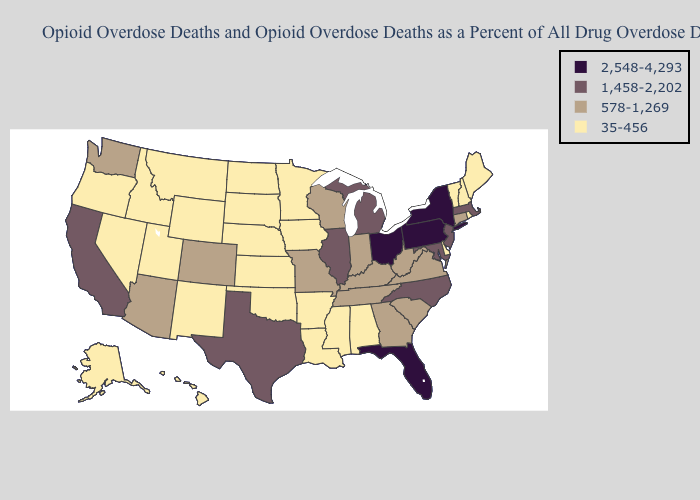Does Arkansas have a lower value than Wyoming?
Answer briefly. No. Does Missouri have the lowest value in the MidWest?
Give a very brief answer. No. What is the value of Texas?
Concise answer only. 1,458-2,202. What is the highest value in the USA?
Be succinct. 2,548-4,293. Does the first symbol in the legend represent the smallest category?
Answer briefly. No. Name the states that have a value in the range 578-1,269?
Write a very short answer. Arizona, Colorado, Connecticut, Georgia, Indiana, Kentucky, Missouri, South Carolina, Tennessee, Virginia, Washington, West Virginia, Wisconsin. What is the highest value in the MidWest ?
Answer briefly. 2,548-4,293. Name the states that have a value in the range 2,548-4,293?
Be succinct. Florida, New York, Ohio, Pennsylvania. Does Michigan have a higher value than Massachusetts?
Answer briefly. No. Does Alabama have the lowest value in the South?
Quick response, please. Yes. Which states have the lowest value in the USA?
Answer briefly. Alabama, Alaska, Arkansas, Delaware, Hawaii, Idaho, Iowa, Kansas, Louisiana, Maine, Minnesota, Mississippi, Montana, Nebraska, Nevada, New Hampshire, New Mexico, North Dakota, Oklahoma, Oregon, Rhode Island, South Dakota, Utah, Vermont, Wyoming. What is the highest value in states that border Texas?
Keep it brief. 35-456. Does Oregon have a lower value than Michigan?
Be succinct. Yes. 